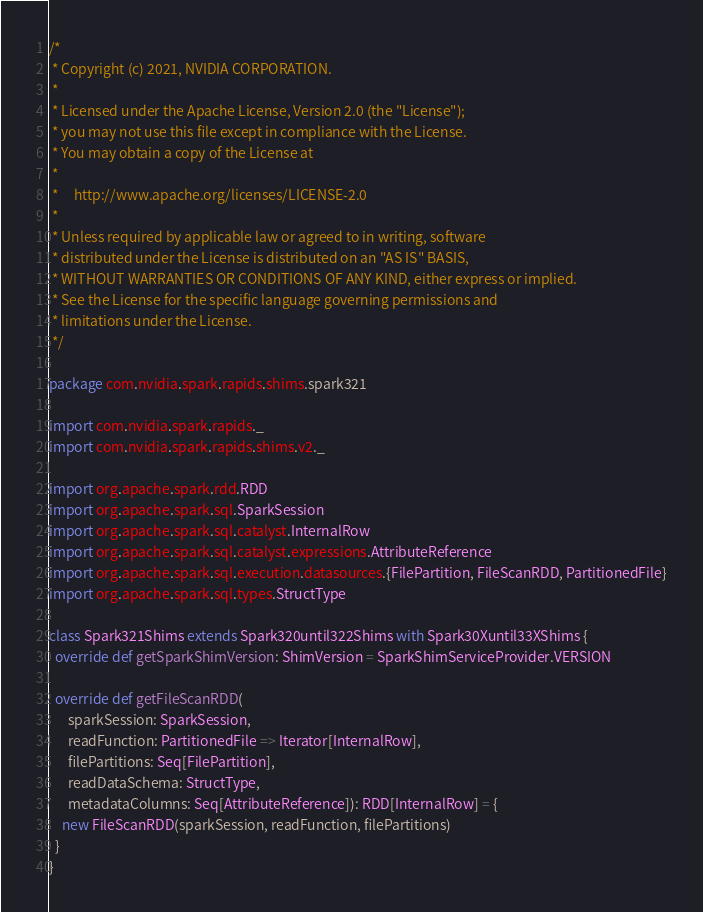Convert code to text. <code><loc_0><loc_0><loc_500><loc_500><_Scala_>/*
 * Copyright (c) 2021, NVIDIA CORPORATION.
 *
 * Licensed under the Apache License, Version 2.0 (the "License");
 * you may not use this file except in compliance with the License.
 * You may obtain a copy of the License at
 *
 *     http://www.apache.org/licenses/LICENSE-2.0
 *
 * Unless required by applicable law or agreed to in writing, software
 * distributed under the License is distributed on an "AS IS" BASIS,
 * WITHOUT WARRANTIES OR CONDITIONS OF ANY KIND, either express or implied.
 * See the License for the specific language governing permissions and
 * limitations under the License.
 */

package com.nvidia.spark.rapids.shims.spark321

import com.nvidia.spark.rapids._
import com.nvidia.spark.rapids.shims.v2._

import org.apache.spark.rdd.RDD
import org.apache.spark.sql.SparkSession
import org.apache.spark.sql.catalyst.InternalRow
import org.apache.spark.sql.catalyst.expressions.AttributeReference
import org.apache.spark.sql.execution.datasources.{FilePartition, FileScanRDD, PartitionedFile}
import org.apache.spark.sql.types.StructType

class Spark321Shims extends Spark320until322Shims with Spark30Xuntil33XShims {
  override def getSparkShimVersion: ShimVersion = SparkShimServiceProvider.VERSION

  override def getFileScanRDD(
      sparkSession: SparkSession,
      readFunction: PartitionedFile => Iterator[InternalRow],
      filePartitions: Seq[FilePartition],
      readDataSchema: StructType,
      metadataColumns: Seq[AttributeReference]): RDD[InternalRow] = {
    new FileScanRDD(sparkSession, readFunction, filePartitions)
  }
}
</code> 